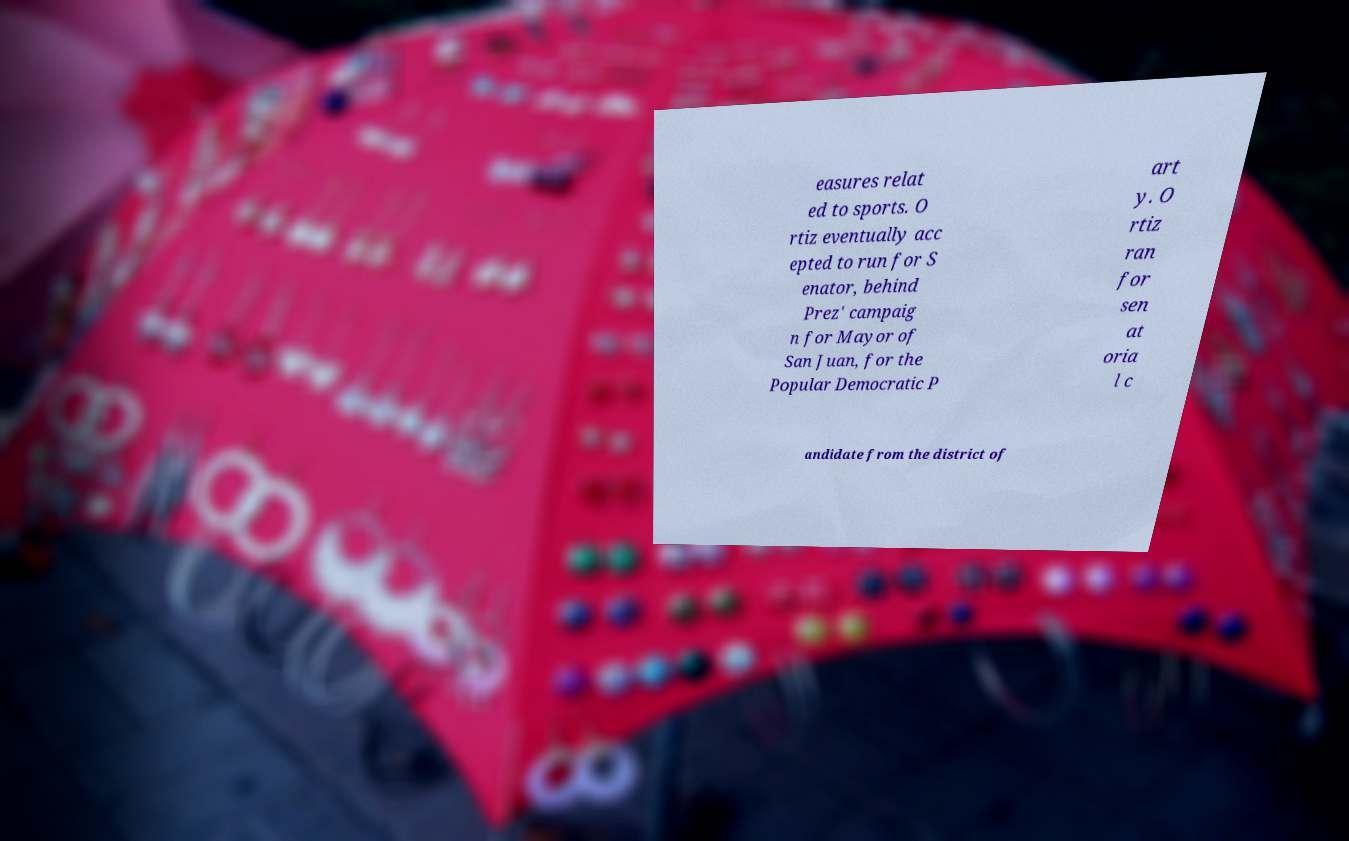What messages or text are displayed in this image? I need them in a readable, typed format. easures relat ed to sports. O rtiz eventually acc epted to run for S enator, behind Prez' campaig n for Mayor of San Juan, for the Popular Democratic P art y. O rtiz ran for sen at oria l c andidate from the district of 